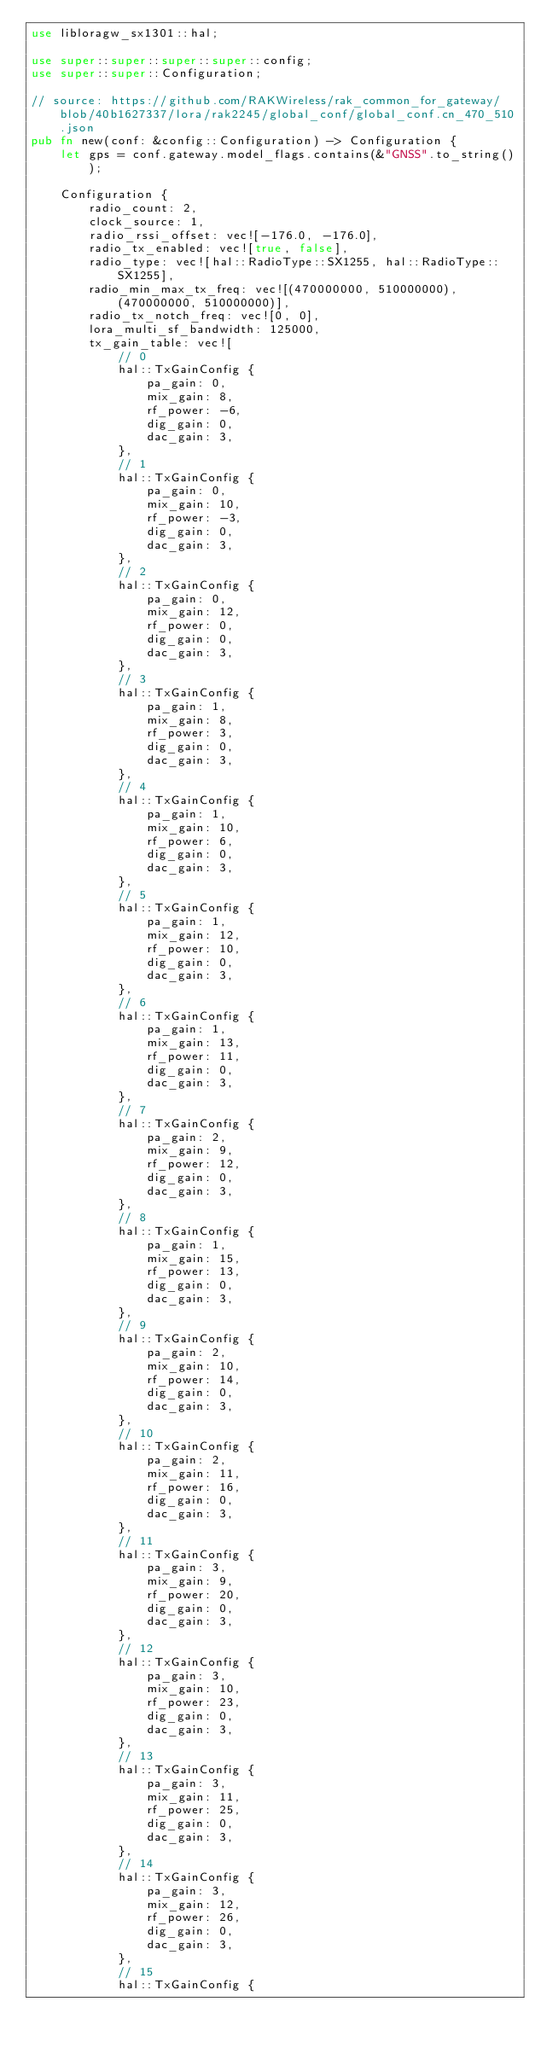<code> <loc_0><loc_0><loc_500><loc_500><_Rust_>use libloragw_sx1301::hal;

use super::super::super::super::config;
use super::super::Configuration;

// source: https://github.com/RAKWireless/rak_common_for_gateway/blob/40b1627337/lora/rak2245/global_conf/global_conf.cn_470_510.json
pub fn new(conf: &config::Configuration) -> Configuration {
    let gps = conf.gateway.model_flags.contains(&"GNSS".to_string());

    Configuration {
        radio_count: 2,
        clock_source: 1,
        radio_rssi_offset: vec![-176.0, -176.0],
        radio_tx_enabled: vec![true, false],
        radio_type: vec![hal::RadioType::SX1255, hal::RadioType::SX1255],
        radio_min_max_tx_freq: vec![(470000000, 510000000), (470000000, 510000000)],
        radio_tx_notch_freq: vec![0, 0],
        lora_multi_sf_bandwidth: 125000,
        tx_gain_table: vec![
            // 0
            hal::TxGainConfig {
                pa_gain: 0,
                mix_gain: 8,
                rf_power: -6,
                dig_gain: 0,
                dac_gain: 3,
            },
            // 1
            hal::TxGainConfig {
                pa_gain: 0,
                mix_gain: 10,
                rf_power: -3,
                dig_gain: 0,
                dac_gain: 3,
            },
            // 2
            hal::TxGainConfig {
                pa_gain: 0,
                mix_gain: 12,
                rf_power: 0,
                dig_gain: 0,
                dac_gain: 3,
            },
            // 3
            hal::TxGainConfig {
                pa_gain: 1,
                mix_gain: 8,
                rf_power: 3,
                dig_gain: 0,
                dac_gain: 3,
            },
            // 4
            hal::TxGainConfig {
                pa_gain: 1,
                mix_gain: 10,
                rf_power: 6,
                dig_gain: 0,
                dac_gain: 3,
            },
            // 5
            hal::TxGainConfig {
                pa_gain: 1,
                mix_gain: 12,
                rf_power: 10,
                dig_gain: 0,
                dac_gain: 3,
            },
            // 6
            hal::TxGainConfig {
                pa_gain: 1,
                mix_gain: 13,
                rf_power: 11,
                dig_gain: 0,
                dac_gain: 3,
            },
            // 7
            hal::TxGainConfig {
                pa_gain: 2,
                mix_gain: 9,
                rf_power: 12,
                dig_gain: 0,
                dac_gain: 3,
            },
            // 8
            hal::TxGainConfig {
                pa_gain: 1,
                mix_gain: 15,
                rf_power: 13,
                dig_gain: 0,
                dac_gain: 3,
            },
            // 9
            hal::TxGainConfig {
                pa_gain: 2,
                mix_gain: 10,
                rf_power: 14,
                dig_gain: 0,
                dac_gain: 3,
            },
            // 10
            hal::TxGainConfig {
                pa_gain: 2,
                mix_gain: 11,
                rf_power: 16,
                dig_gain: 0,
                dac_gain: 3,
            },
            // 11
            hal::TxGainConfig {
                pa_gain: 3,
                mix_gain: 9,
                rf_power: 20,
                dig_gain: 0,
                dac_gain: 3,
            },
            // 12
            hal::TxGainConfig {
                pa_gain: 3,
                mix_gain: 10,
                rf_power: 23,
                dig_gain: 0,
                dac_gain: 3,
            },
            // 13
            hal::TxGainConfig {
                pa_gain: 3,
                mix_gain: 11,
                rf_power: 25,
                dig_gain: 0,
                dac_gain: 3,
            },
            // 14
            hal::TxGainConfig {
                pa_gain: 3,
                mix_gain: 12,
                rf_power: 26,
                dig_gain: 0,
                dac_gain: 3,
            },
            // 15
            hal::TxGainConfig {</code> 